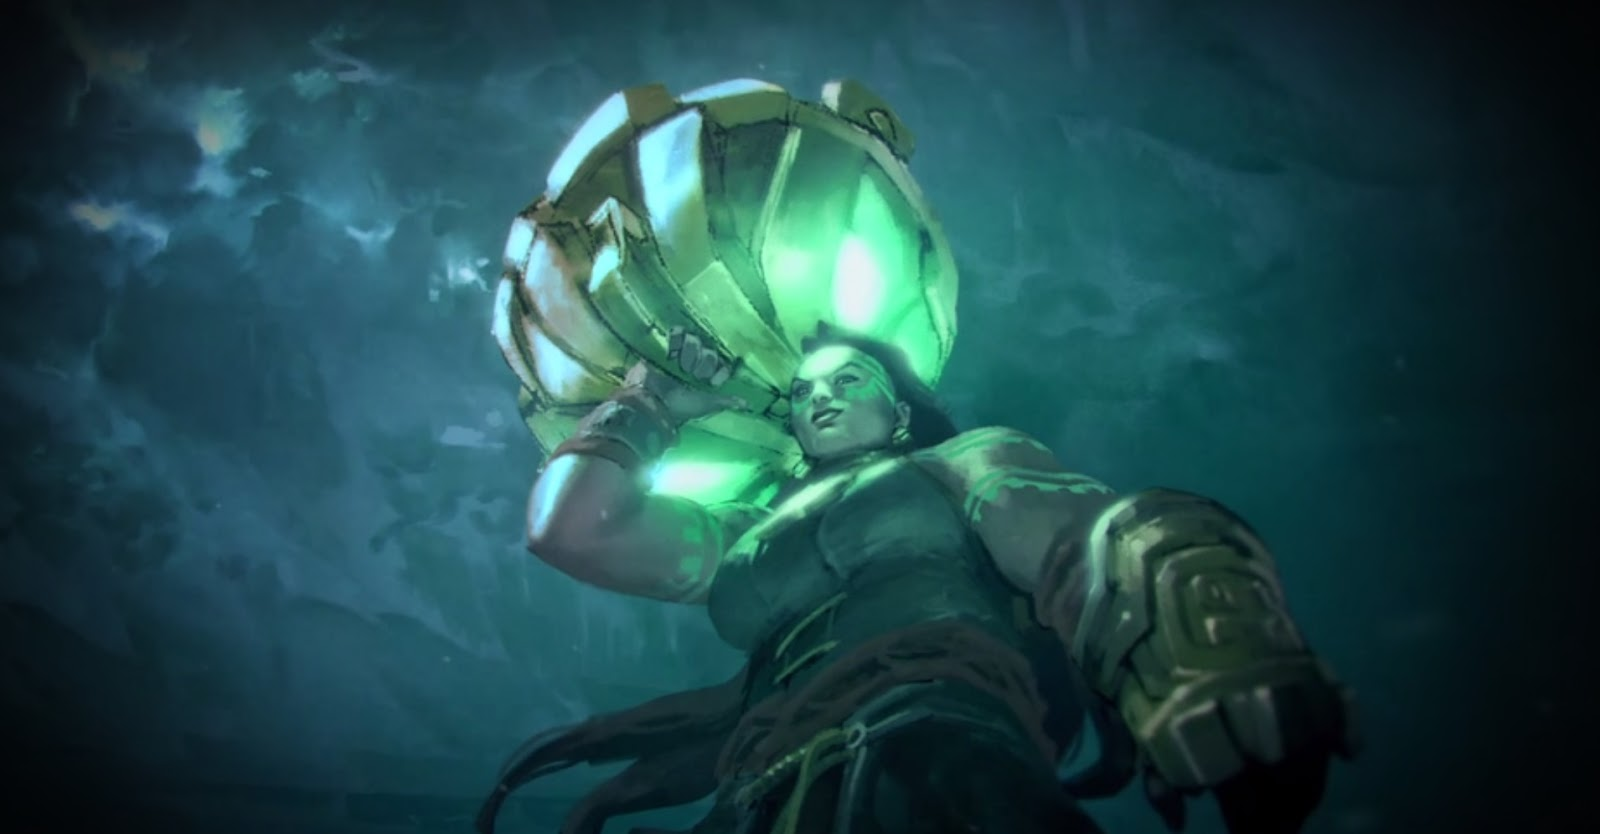How does the technology embedded in the character's suit assist in their mission? The technology in the character's suit is likely multifaceted, designed to support a range of underwater activities. Features like the helmet's light source enhance visibility in the dark depths of the ocean. The suit's thick armor not only protects against physical impacts and high water pressure but could also be equipped with sensors to monitor the character's vitals and surrounding environmental conditions, like water temperature and pressure. The suit may also include communication technology to stay in contact with surface teams, enabling real-time data exchange and strategic decision-making during the mission. What kind of tools might the character be using along with the suit? Alongside the suit, the character might use a variety of specialized tools depending on the mission specifics. These could include underwater propulsion devices for swift movement across the ocean floor, robotic arms for sample collection or interaction with the environment, and possibly weapons for defense against underwater creatures. Advanced scanning tools could also be utilized to map the seafloor and detect resources or anomalies. 